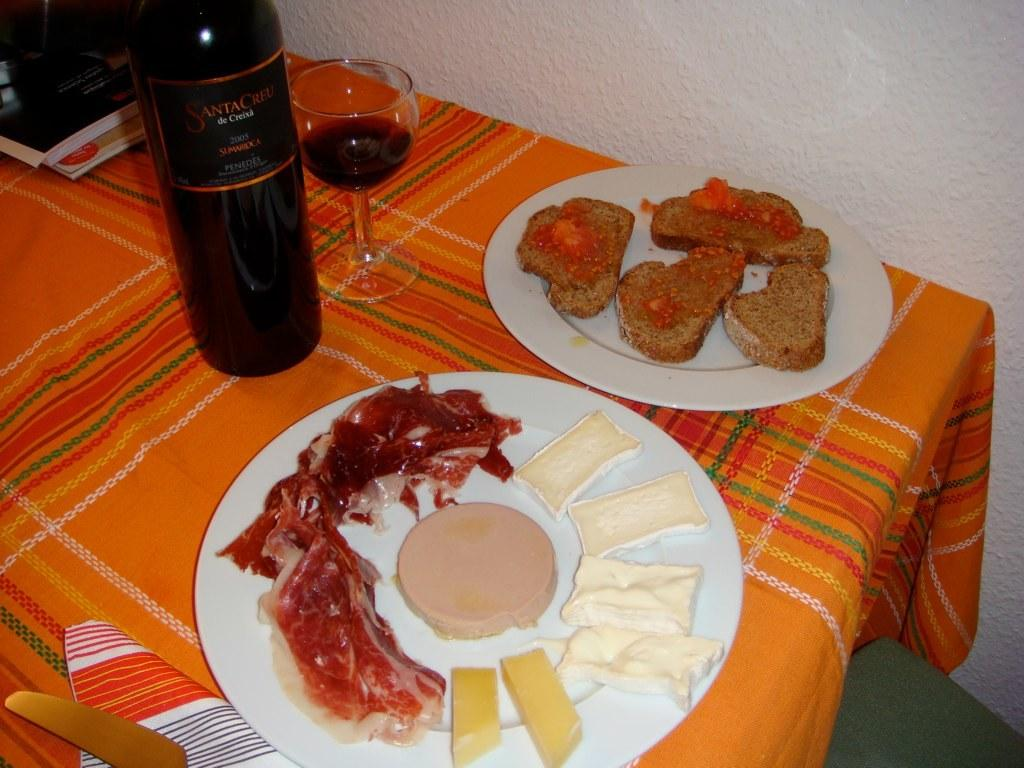<image>
Render a clear and concise summary of the photo. Black bottle with a label that says "Santa Creu" on it. 